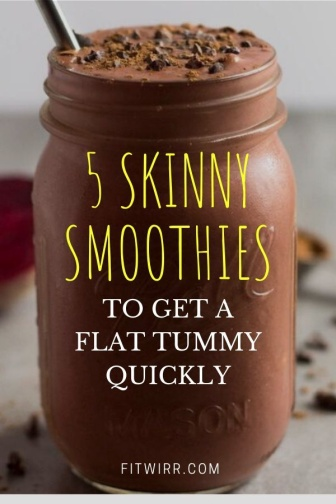Can you elaborate on the elements of the picture provided? The image captures a delightful scene of a chocolate smoothie in a mason jar, which is the central focus. The jar, filled to the brim with the rich, creamy beverage, is equipped with a metal straw, ready for sipping. 

The jar is adorned with a label in a contrasting black and yellow color scheme. The yellow text on the label announces "5 SKINNY SMOOTHIES TO GET A FLAT TUMMY QUICKLY", perhaps suggesting the health benefits of the drink inside.

The jar is placed on a white countertop, which provides a clean, minimalist backdrop to the scene. Adding a touch of whimsy and color to the composition are chocolate chips and a single raspberry, scattered casually around the jar on the countertop. 

The overall arrangement of the objects suggests a carefully staged yet casual setting, possibly intended to evoke a sense of healthy indulgence. The image seems to invite the viewer to partake in the enjoyment of a delicious, yet health-conscious beverage. 